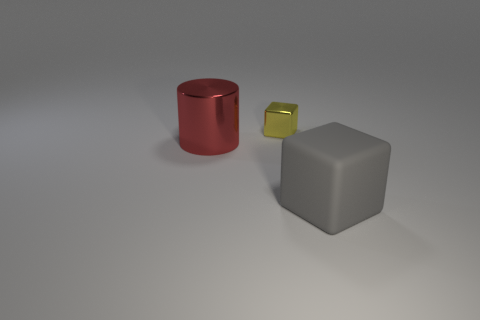Are there any other things that are the same size as the yellow block?
Offer a very short reply. No. There is a metallic thing in front of the small object; how many blocks are in front of it?
Offer a very short reply. 1. Are there any yellow objects behind the tiny object?
Provide a short and direct response. No. There is a large object that is behind the thing that is in front of the metal cylinder; what is its shape?
Offer a terse response. Cylinder. Are there fewer small objects in front of the small object than yellow cubes behind the cylinder?
Offer a terse response. Yes. What is the color of the rubber object that is the same shape as the yellow metal object?
Make the answer very short. Gray. How many things are both on the right side of the big metallic object and behind the big block?
Give a very brief answer. 1. Are there more shiny objects that are behind the big metal thing than big metal things that are behind the yellow thing?
Your response must be concise. Yes. The yellow metal object is what size?
Your answer should be very brief. Small. Is there a large red metal object that has the same shape as the matte thing?
Provide a succinct answer. No. 